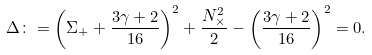<formula> <loc_0><loc_0><loc_500><loc_500>\Delta \colon = \left ( \Sigma _ { + } + \frac { 3 \gamma + 2 } { 1 6 } \right ) ^ { 2 } + \frac { N _ { \times } ^ { 2 } } { 2 } - \left ( \frac { 3 \gamma + 2 } { 1 6 } \right ) ^ { 2 } = 0 .</formula> 